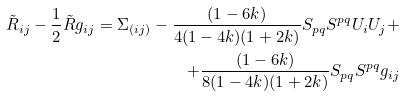<formula> <loc_0><loc_0><loc_500><loc_500>\tilde { R } _ { i j } - \frac { 1 } { 2 } \tilde { R } g _ { i j } = \Sigma _ { ( i j ) } - \frac { ( 1 - 6 k ) } { 4 ( 1 - 4 k ) ( 1 + 2 k ) } S _ { p q } S ^ { p q } U _ { i } U _ { j } + \\ + \frac { ( 1 - 6 k ) } { 8 ( 1 - 4 k ) ( 1 + 2 k ) } S _ { p q } S ^ { p q } g _ { i j }</formula> 